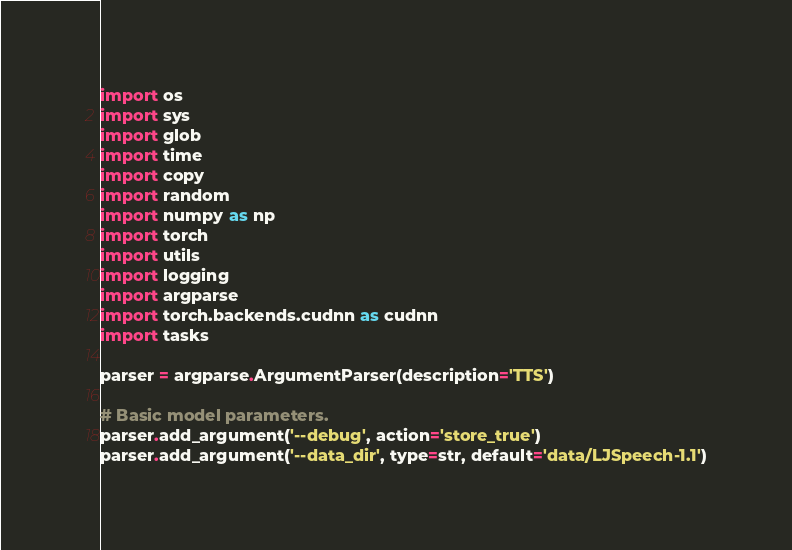Convert code to text. <code><loc_0><loc_0><loc_500><loc_500><_Python_>import os
import sys
import glob
import time
import copy
import random
import numpy as np
import torch
import utils
import logging
import argparse
import torch.backends.cudnn as cudnn
import tasks

parser = argparse.ArgumentParser(description='TTS')

# Basic model parameters.
parser.add_argument('--debug', action='store_true')
parser.add_argument('--data_dir', type=str, default='data/LJSpeech-1.1')</code> 